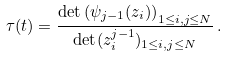<formula> <loc_0><loc_0><loc_500><loc_500>\tau ( t ) = \frac { \det \left ( \psi _ { j - 1 } ( z _ { i } ) \right ) _ { 1 \leq i , j \leq N } } { \det ( z _ { i } ^ { j - 1 } ) _ { 1 \leq i , j \leq N } } \, .</formula> 